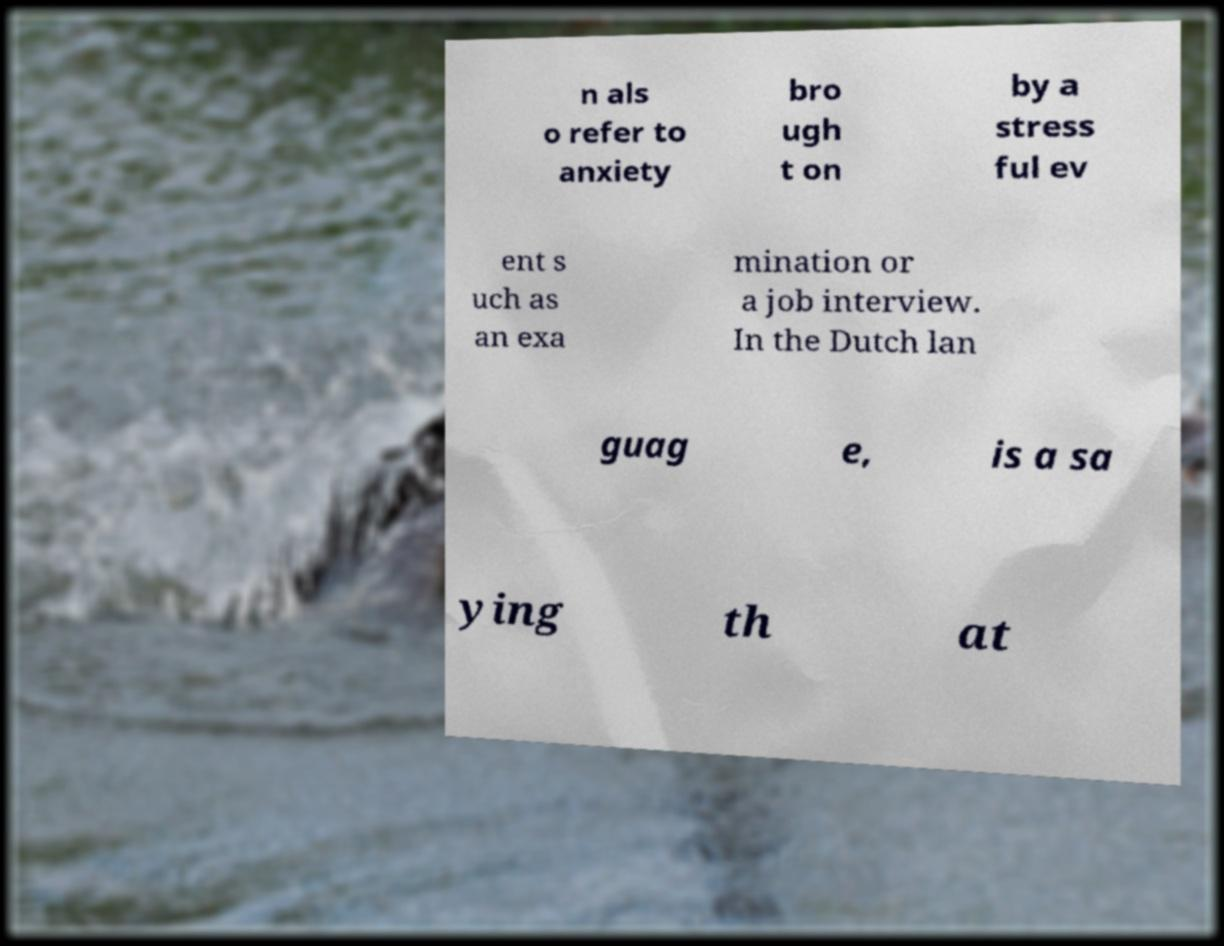For documentation purposes, I need the text within this image transcribed. Could you provide that? n als o refer to anxiety bro ugh t on by a stress ful ev ent s uch as an exa mination or a job interview. In the Dutch lan guag e, is a sa ying th at 